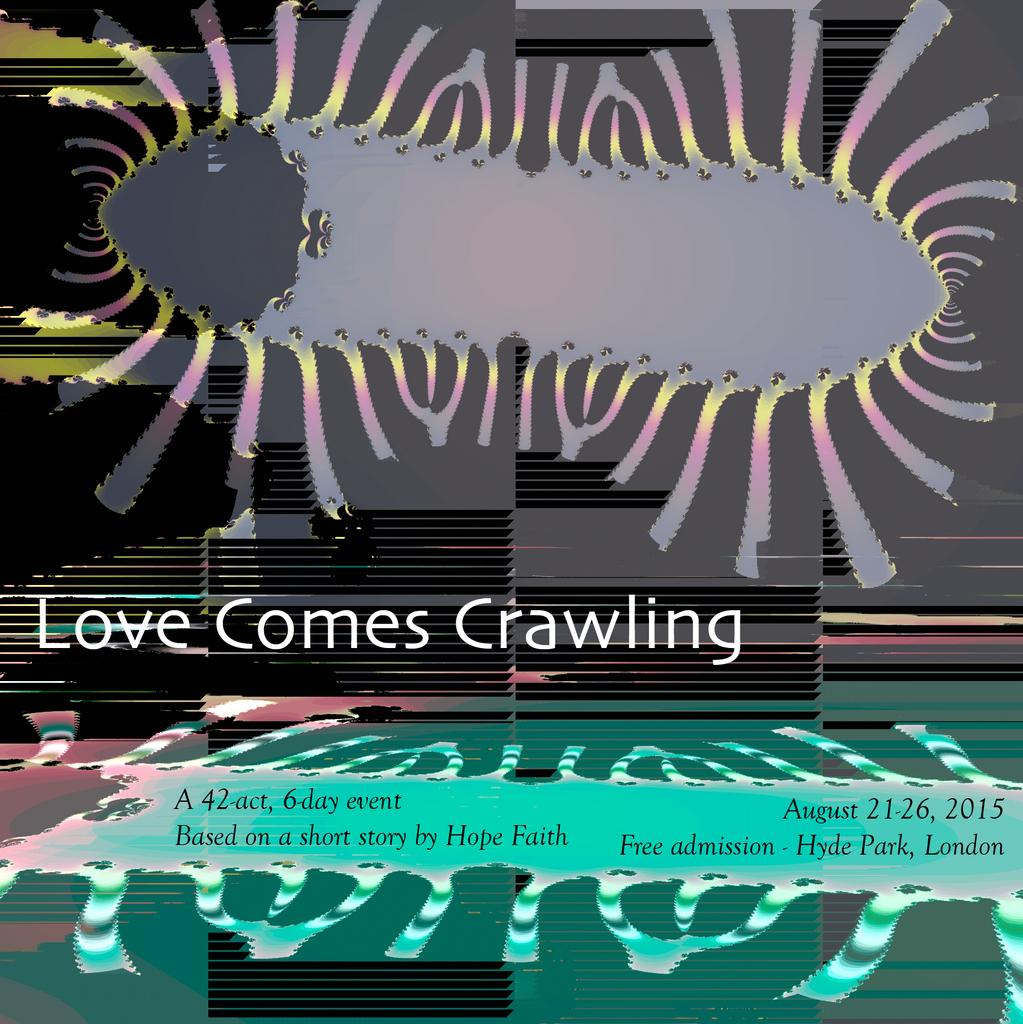<image>
Summarize the visual content of the image. a play poster that says 'love comes crawling' 